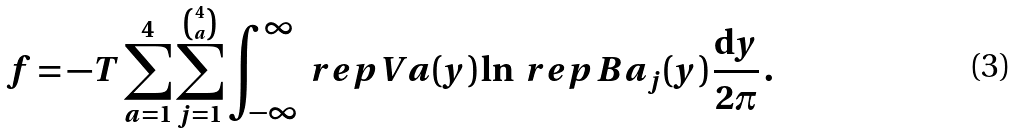Convert formula to latex. <formula><loc_0><loc_0><loc_500><loc_500>f = - T \sum _ { a = 1 } ^ { 4 } \sum _ { j = 1 } ^ { \binom { 4 } { a } } \int _ { - \infty } ^ { \infty } \ r e p { V } { a } ( y ) \ln \ r e p { B } { a } _ { j } ( y ) \, \frac { \mathrm d y } { 2 \pi } \, .</formula> 